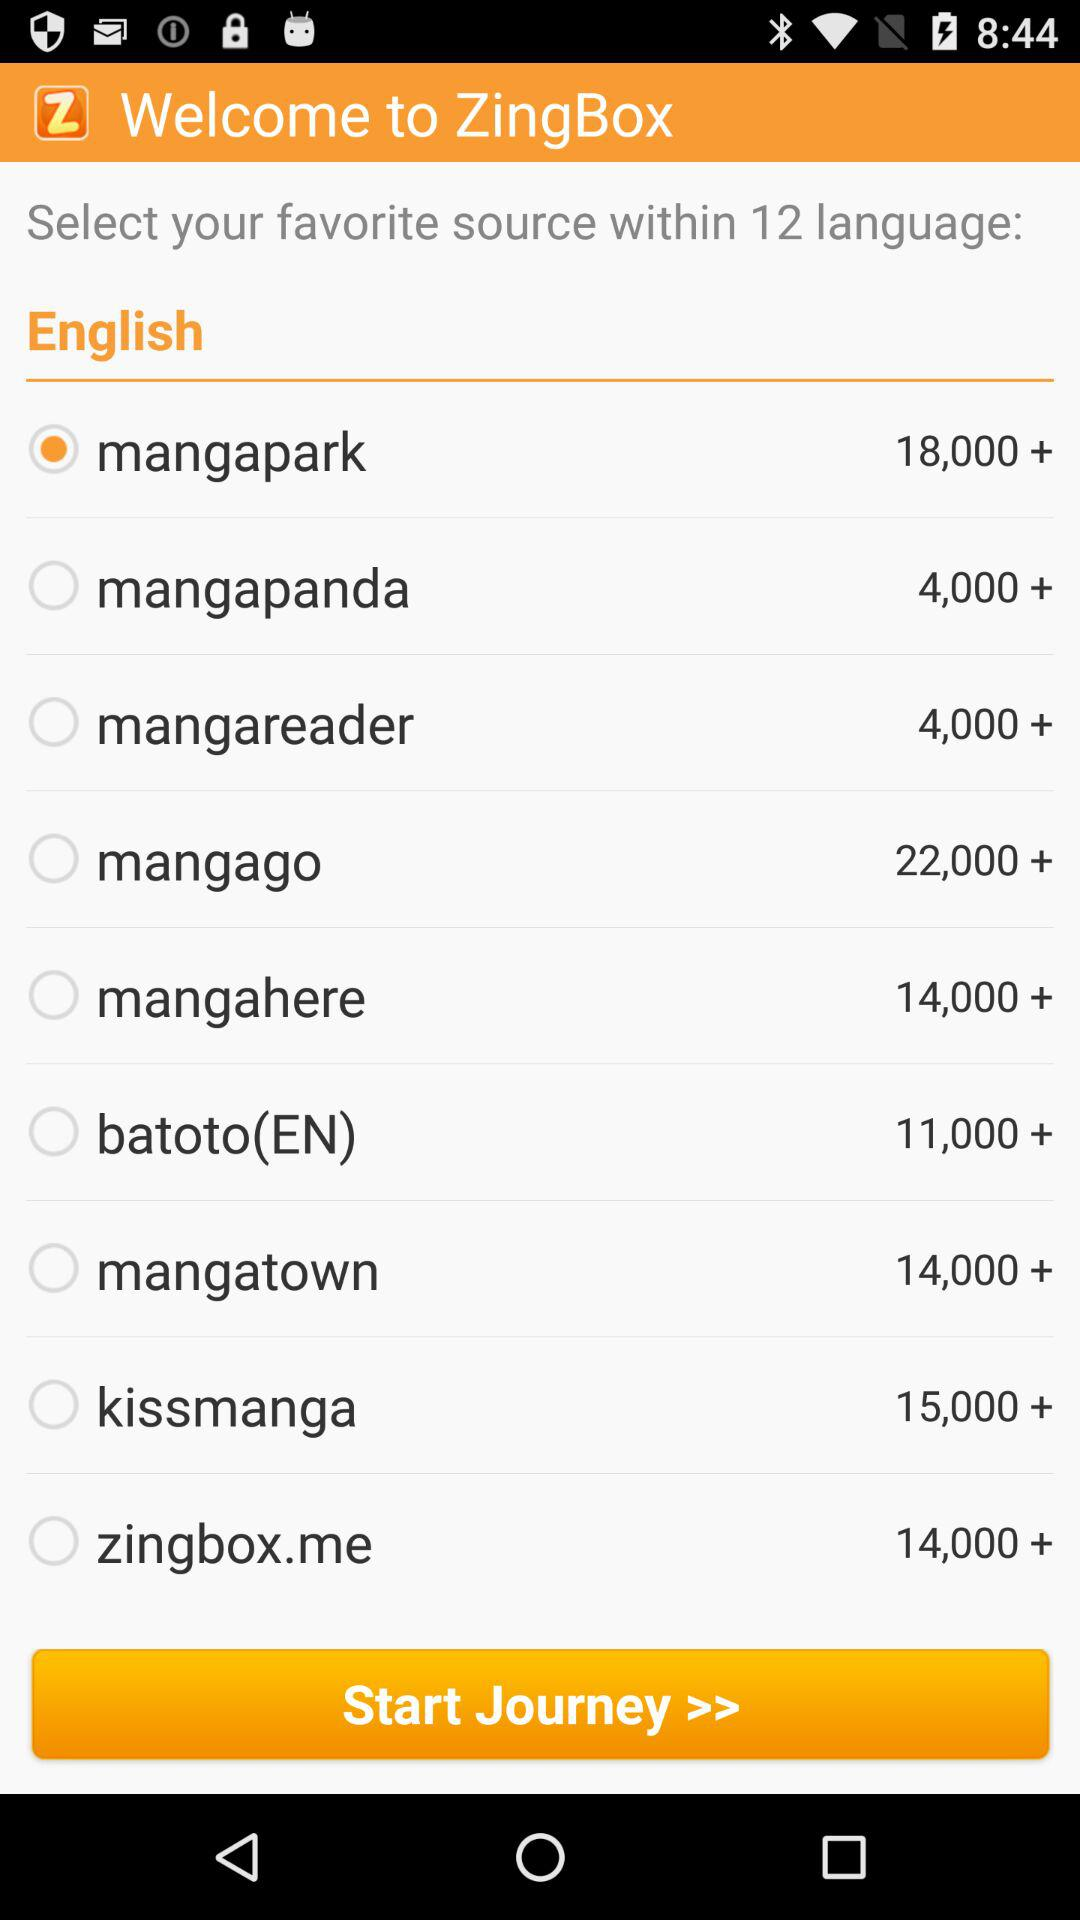How many mangas does zingbox.me have? There are more than 14,000 mangas in zingbox.me. 